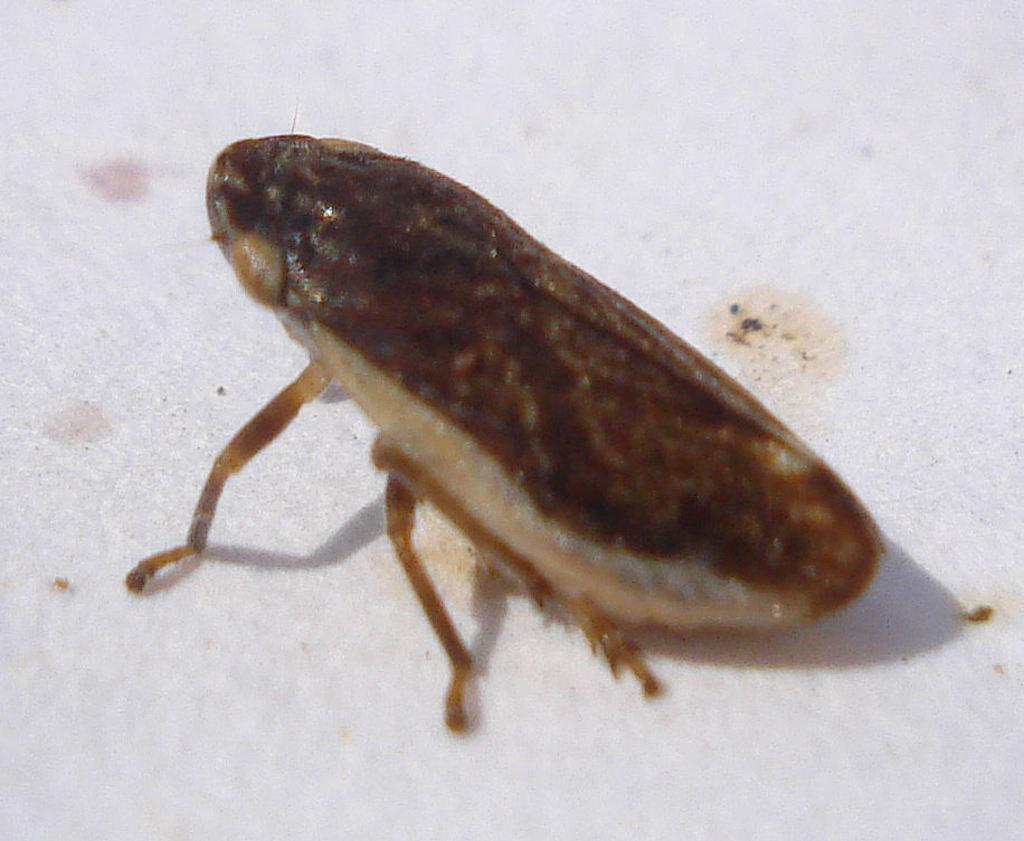What type of creature can be seen in the image? There is an insect in the image. What type of band is playing music in the image? There is no band present in the image; it only features an insect. 